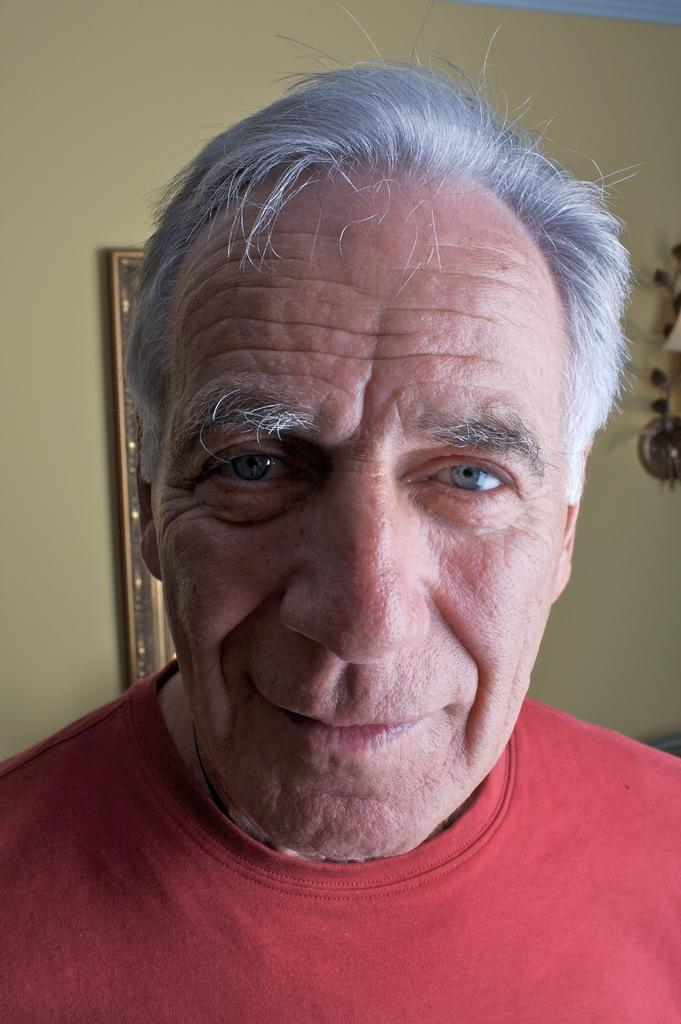Who or what is the main subject in the image? There is a person in the image. Can you describe the position of the person in the image? The person is in front. What can be seen behind the person in the image? There are objects on the wall behind the person. Reasoning: Let'g: Let's think step by step in order to produce the conversation. We start by identifying the main subject in the image, which is the person. Then, we describe the position of the person in the image, noting that they are in front. Finally, we mention the objects on the wall behind the person, providing additional context about the setting. Absurd Question/Answer: What type of cat is sitting next to the person in the image? There is no cat present in the image; the main subject is a person. What is the person's opinion on the use of a rake in the image? The image does not provide any information about the person's opinion on the use of a rake, as there is no rake present in the image. 